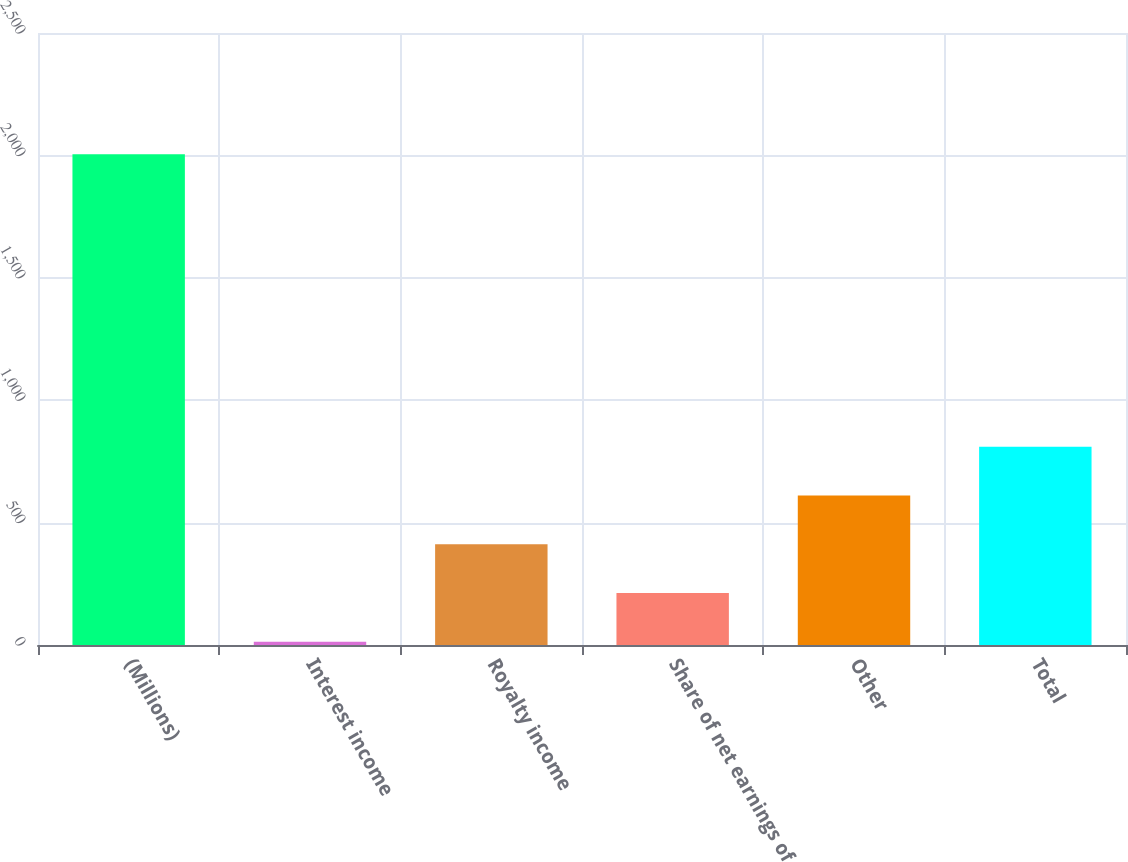Convert chart to OTSL. <chart><loc_0><loc_0><loc_500><loc_500><bar_chart><fcel>(Millions)<fcel>Interest income<fcel>Royalty income<fcel>Share of net earnings of<fcel>Other<fcel>Total<nl><fcel>2005<fcel>13<fcel>411.4<fcel>212.2<fcel>610.6<fcel>809.8<nl></chart> 